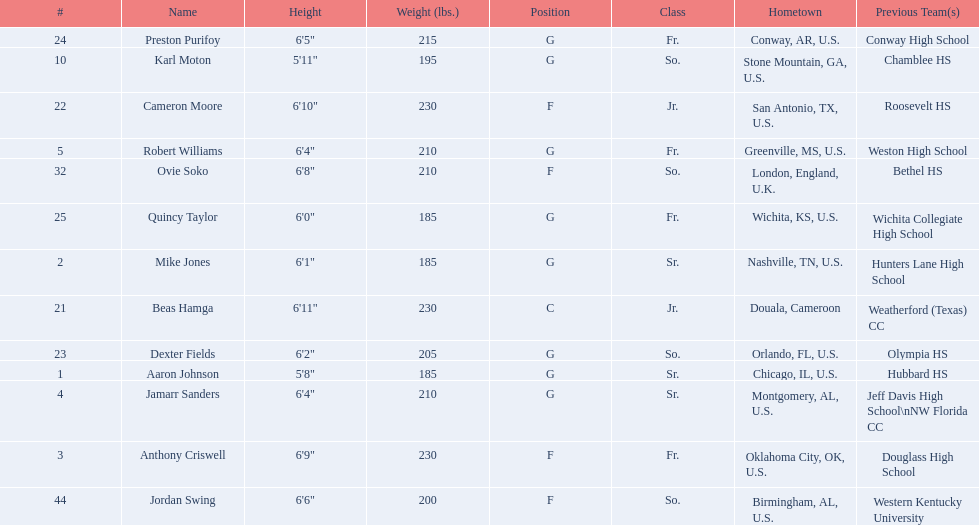Tell me the number of juniors on the team. 2. 